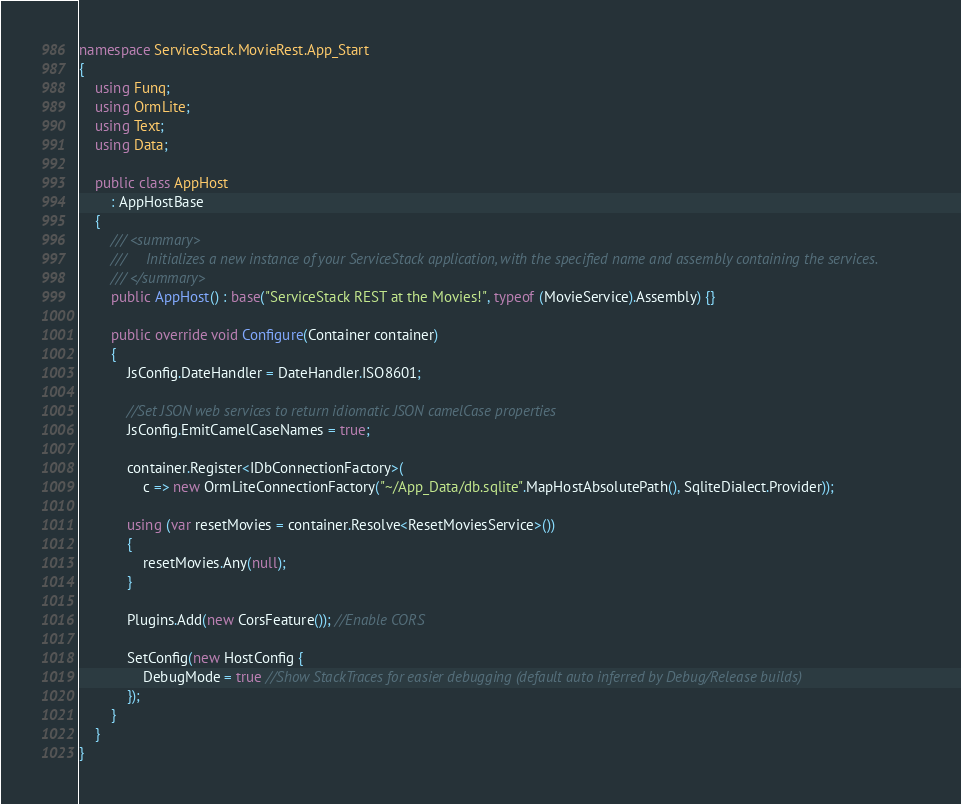Convert code to text. <code><loc_0><loc_0><loc_500><loc_500><_C#_>
namespace ServiceStack.MovieRest.App_Start
{
	using Funq;
	using OrmLite;
	using Text;
    using Data;

    public class AppHost
		: AppHostBase
	{
		/// <summary>
		///     Initializes a new instance of your ServiceStack application, with the specified name and assembly containing the services.
		/// </summary>
		public AppHost() : base("ServiceStack REST at the Movies!", typeof (MovieService).Assembly) {}

		public override void Configure(Container container)
		{
			JsConfig.DateHandler = DateHandler.ISO8601;

			//Set JSON web services to return idiomatic JSON camelCase properties
			JsConfig.EmitCamelCaseNames = true;

			container.Register<IDbConnectionFactory>(
				c => new OrmLiteConnectionFactory("~/App_Data/db.sqlite".MapHostAbsolutePath(), SqliteDialect.Provider));

			using (var resetMovies = container.Resolve<ResetMoviesService>())
			{
				resetMovies.Any(null);
			}

			Plugins.Add(new CorsFeature()); //Enable CORS

			SetConfig(new HostConfig {
				DebugMode = true //Show StackTraces for easier debugging (default auto inferred by Debug/Release builds)
			});
		}
	}
}</code> 